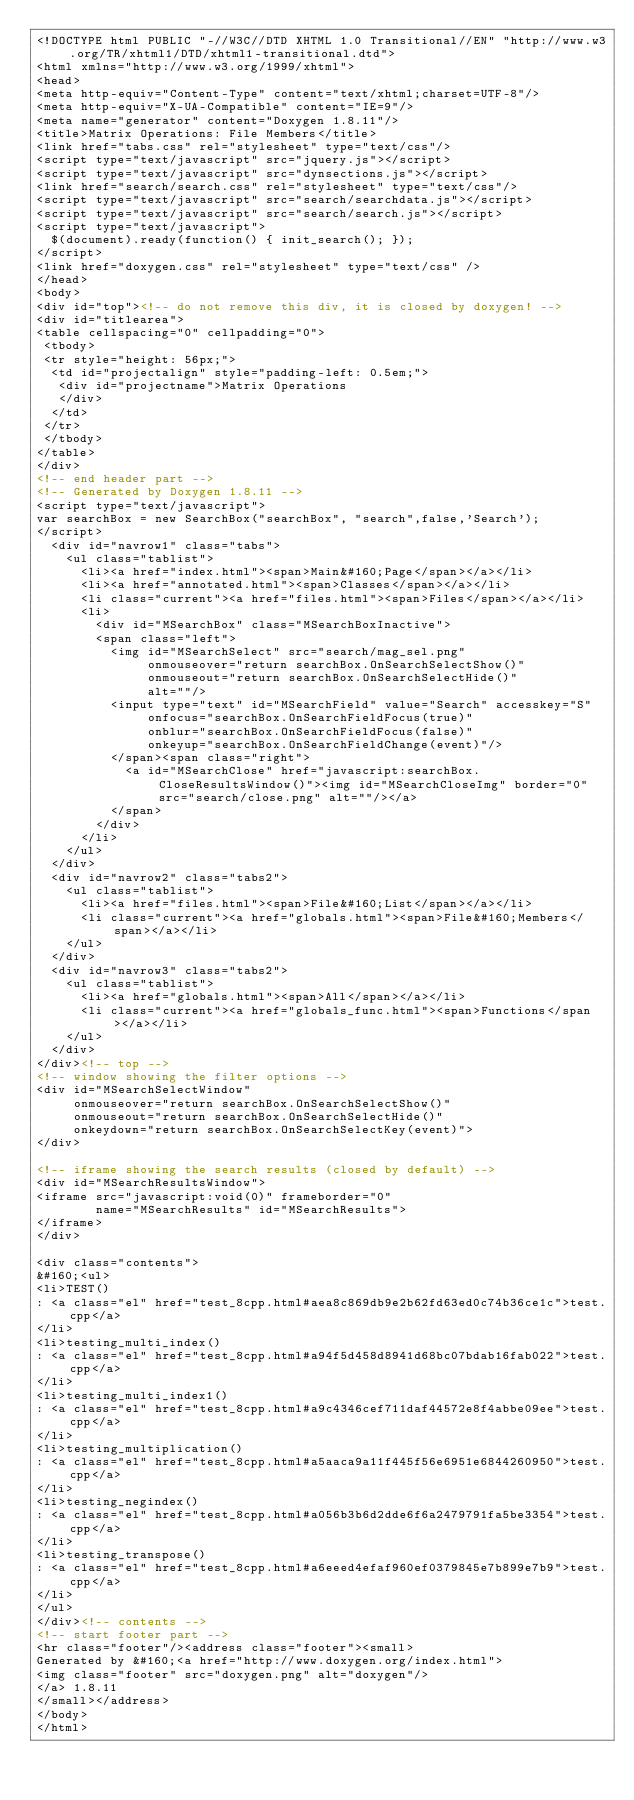Convert code to text. <code><loc_0><loc_0><loc_500><loc_500><_HTML_><!DOCTYPE html PUBLIC "-//W3C//DTD XHTML 1.0 Transitional//EN" "http://www.w3.org/TR/xhtml1/DTD/xhtml1-transitional.dtd">
<html xmlns="http://www.w3.org/1999/xhtml">
<head>
<meta http-equiv="Content-Type" content="text/xhtml;charset=UTF-8"/>
<meta http-equiv="X-UA-Compatible" content="IE=9"/>
<meta name="generator" content="Doxygen 1.8.11"/>
<title>Matrix Operations: File Members</title>
<link href="tabs.css" rel="stylesheet" type="text/css"/>
<script type="text/javascript" src="jquery.js"></script>
<script type="text/javascript" src="dynsections.js"></script>
<link href="search/search.css" rel="stylesheet" type="text/css"/>
<script type="text/javascript" src="search/searchdata.js"></script>
<script type="text/javascript" src="search/search.js"></script>
<script type="text/javascript">
  $(document).ready(function() { init_search(); });
</script>
<link href="doxygen.css" rel="stylesheet" type="text/css" />
</head>
<body>
<div id="top"><!-- do not remove this div, it is closed by doxygen! -->
<div id="titlearea">
<table cellspacing="0" cellpadding="0">
 <tbody>
 <tr style="height: 56px;">
  <td id="projectalign" style="padding-left: 0.5em;">
   <div id="projectname">Matrix Operations
   </div>
  </td>
 </tr>
 </tbody>
</table>
</div>
<!-- end header part -->
<!-- Generated by Doxygen 1.8.11 -->
<script type="text/javascript">
var searchBox = new SearchBox("searchBox", "search",false,'Search');
</script>
  <div id="navrow1" class="tabs">
    <ul class="tablist">
      <li><a href="index.html"><span>Main&#160;Page</span></a></li>
      <li><a href="annotated.html"><span>Classes</span></a></li>
      <li class="current"><a href="files.html"><span>Files</span></a></li>
      <li>
        <div id="MSearchBox" class="MSearchBoxInactive">
        <span class="left">
          <img id="MSearchSelect" src="search/mag_sel.png"
               onmouseover="return searchBox.OnSearchSelectShow()"
               onmouseout="return searchBox.OnSearchSelectHide()"
               alt=""/>
          <input type="text" id="MSearchField" value="Search" accesskey="S"
               onfocus="searchBox.OnSearchFieldFocus(true)" 
               onblur="searchBox.OnSearchFieldFocus(false)" 
               onkeyup="searchBox.OnSearchFieldChange(event)"/>
          </span><span class="right">
            <a id="MSearchClose" href="javascript:searchBox.CloseResultsWindow()"><img id="MSearchCloseImg" border="0" src="search/close.png" alt=""/></a>
          </span>
        </div>
      </li>
    </ul>
  </div>
  <div id="navrow2" class="tabs2">
    <ul class="tablist">
      <li><a href="files.html"><span>File&#160;List</span></a></li>
      <li class="current"><a href="globals.html"><span>File&#160;Members</span></a></li>
    </ul>
  </div>
  <div id="navrow3" class="tabs2">
    <ul class="tablist">
      <li><a href="globals.html"><span>All</span></a></li>
      <li class="current"><a href="globals_func.html"><span>Functions</span></a></li>
    </ul>
  </div>
</div><!-- top -->
<!-- window showing the filter options -->
<div id="MSearchSelectWindow"
     onmouseover="return searchBox.OnSearchSelectShow()"
     onmouseout="return searchBox.OnSearchSelectHide()"
     onkeydown="return searchBox.OnSearchSelectKey(event)">
</div>

<!-- iframe showing the search results (closed by default) -->
<div id="MSearchResultsWindow">
<iframe src="javascript:void(0)" frameborder="0" 
        name="MSearchResults" id="MSearchResults">
</iframe>
</div>

<div class="contents">
&#160;<ul>
<li>TEST()
: <a class="el" href="test_8cpp.html#aea8c869db9e2b62fd63ed0c74b36ce1c">test.cpp</a>
</li>
<li>testing_multi_index()
: <a class="el" href="test_8cpp.html#a94f5d458d8941d68bc07bdab16fab022">test.cpp</a>
</li>
<li>testing_multi_index1()
: <a class="el" href="test_8cpp.html#a9c4346cef711daf44572e8f4abbe09ee">test.cpp</a>
</li>
<li>testing_multiplication()
: <a class="el" href="test_8cpp.html#a5aaca9a11f445f56e6951e6844260950">test.cpp</a>
</li>
<li>testing_negindex()
: <a class="el" href="test_8cpp.html#a056b3b6d2dde6f6a2479791fa5be3354">test.cpp</a>
</li>
<li>testing_transpose()
: <a class="el" href="test_8cpp.html#a6eeed4efaf960ef0379845e7b899e7b9">test.cpp</a>
</li>
</ul>
</div><!-- contents -->
<!-- start footer part -->
<hr class="footer"/><address class="footer"><small>
Generated by &#160;<a href="http://www.doxygen.org/index.html">
<img class="footer" src="doxygen.png" alt="doxygen"/>
</a> 1.8.11
</small></address>
</body>
</html>
</code> 